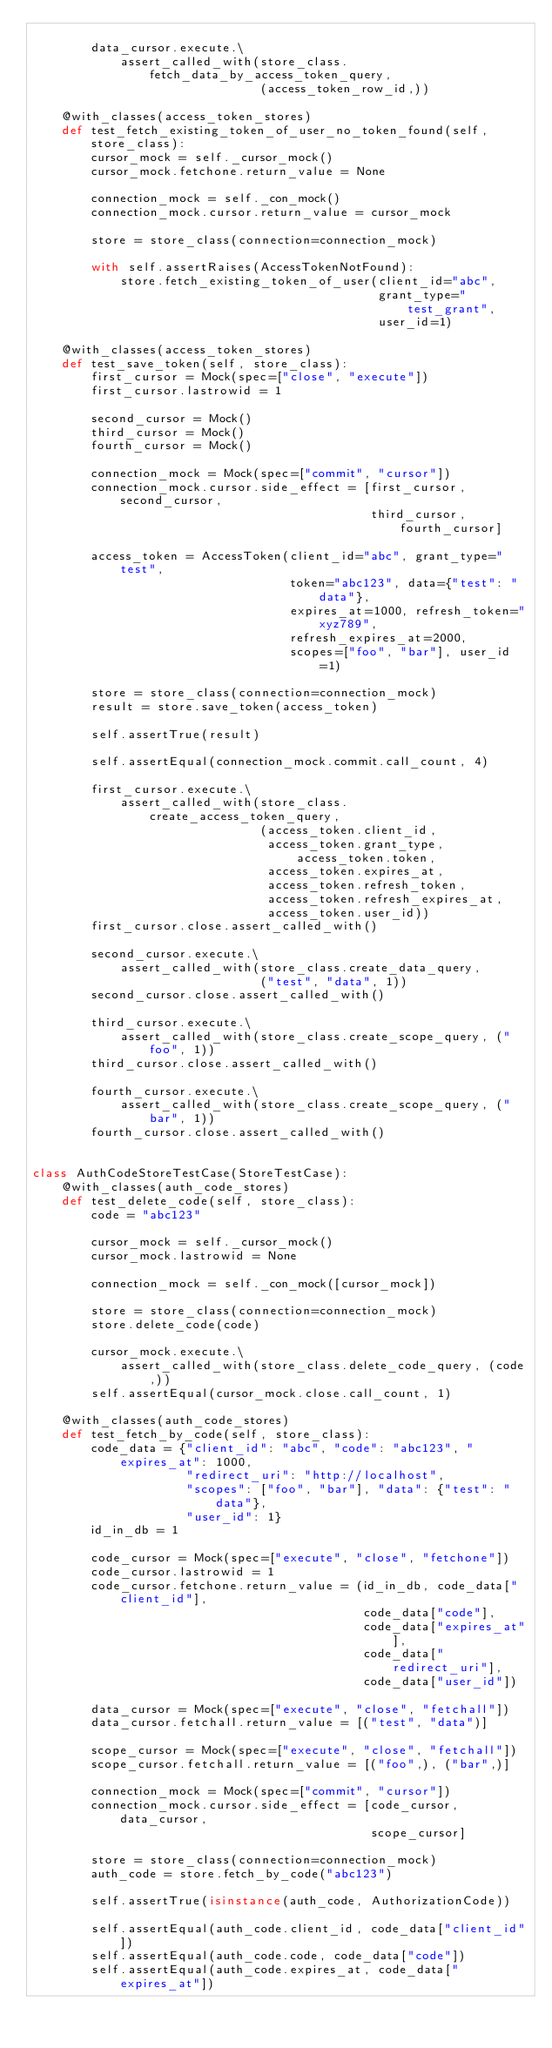Convert code to text. <code><loc_0><loc_0><loc_500><loc_500><_Python_>
        data_cursor.execute.\
            assert_called_with(store_class.fetch_data_by_access_token_query,
                               (access_token_row_id,))

    @with_classes(access_token_stores)
    def test_fetch_existing_token_of_user_no_token_found(self, store_class):
        cursor_mock = self._cursor_mock()
        cursor_mock.fetchone.return_value = None

        connection_mock = self._con_mock()
        connection_mock.cursor.return_value = cursor_mock

        store = store_class(connection=connection_mock)

        with self.assertRaises(AccessTokenNotFound):
            store.fetch_existing_token_of_user(client_id="abc",
                                               grant_type="test_grant",
                                               user_id=1)

    @with_classes(access_token_stores)
    def test_save_token(self, store_class):
        first_cursor = Mock(spec=["close", "execute"])
        first_cursor.lastrowid = 1

        second_cursor = Mock()
        third_cursor = Mock()
        fourth_cursor = Mock()

        connection_mock = Mock(spec=["commit", "cursor"])
        connection_mock.cursor.side_effect = [first_cursor, second_cursor,
                                              third_cursor, fourth_cursor]

        access_token = AccessToken(client_id="abc", grant_type="test",
                                   token="abc123", data={"test": "data"},
                                   expires_at=1000, refresh_token="xyz789",
                                   refresh_expires_at=2000,
                                   scopes=["foo", "bar"], user_id=1)

        store = store_class(connection=connection_mock)
        result = store.save_token(access_token)

        self.assertTrue(result)

        self.assertEqual(connection_mock.commit.call_count, 4)

        first_cursor.execute.\
            assert_called_with(store_class.create_access_token_query,
                               (access_token.client_id,
                                access_token.grant_type, access_token.token,
                                access_token.expires_at,
                                access_token.refresh_token,
                                access_token.refresh_expires_at,
                                access_token.user_id))
        first_cursor.close.assert_called_with()

        second_cursor.execute.\
            assert_called_with(store_class.create_data_query,
                               ("test", "data", 1))
        second_cursor.close.assert_called_with()

        third_cursor.execute.\
            assert_called_with(store_class.create_scope_query, ("foo", 1))
        third_cursor.close.assert_called_with()

        fourth_cursor.execute.\
            assert_called_with(store_class.create_scope_query, ("bar", 1))
        fourth_cursor.close.assert_called_with()


class AuthCodeStoreTestCase(StoreTestCase):
    @with_classes(auth_code_stores)
    def test_delete_code(self, store_class):
        code = "abc123"

        cursor_mock = self._cursor_mock()
        cursor_mock.lastrowid = None

        connection_mock = self._con_mock([cursor_mock])

        store = store_class(connection=connection_mock)
        store.delete_code(code)

        cursor_mock.execute.\
            assert_called_with(store_class.delete_code_query, (code,))
        self.assertEqual(cursor_mock.close.call_count, 1)

    @with_classes(auth_code_stores)
    def test_fetch_by_code(self, store_class):
        code_data = {"client_id": "abc", "code": "abc123", "expires_at": 1000,
                     "redirect_uri": "http://localhost",
                     "scopes": ["foo", "bar"], "data": {"test": "data"},
                     "user_id": 1}
        id_in_db = 1

        code_cursor = Mock(spec=["execute", "close", "fetchone"])
        code_cursor.lastrowid = 1
        code_cursor.fetchone.return_value = (id_in_db, code_data["client_id"],
                                             code_data["code"],
                                             code_data["expires_at"],
                                             code_data["redirect_uri"],
                                             code_data["user_id"])

        data_cursor = Mock(spec=["execute", "close", "fetchall"])
        data_cursor.fetchall.return_value = [("test", "data")]

        scope_cursor = Mock(spec=["execute", "close", "fetchall"])
        scope_cursor.fetchall.return_value = [("foo",), ("bar",)]

        connection_mock = Mock(spec=["commit", "cursor"])
        connection_mock.cursor.side_effect = [code_cursor, data_cursor,
                                              scope_cursor]

        store = store_class(connection=connection_mock)
        auth_code = store.fetch_by_code("abc123")

        self.assertTrue(isinstance(auth_code, AuthorizationCode))

        self.assertEqual(auth_code.client_id, code_data["client_id"])
        self.assertEqual(auth_code.code, code_data["code"])
        self.assertEqual(auth_code.expires_at, code_data["expires_at"])</code> 